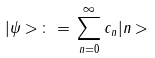Convert formula to latex. <formula><loc_0><loc_0><loc_500><loc_500>| \psi > \, \colon = \, \sum _ { n = 0 } ^ { \infty } c _ { n } | n ></formula> 